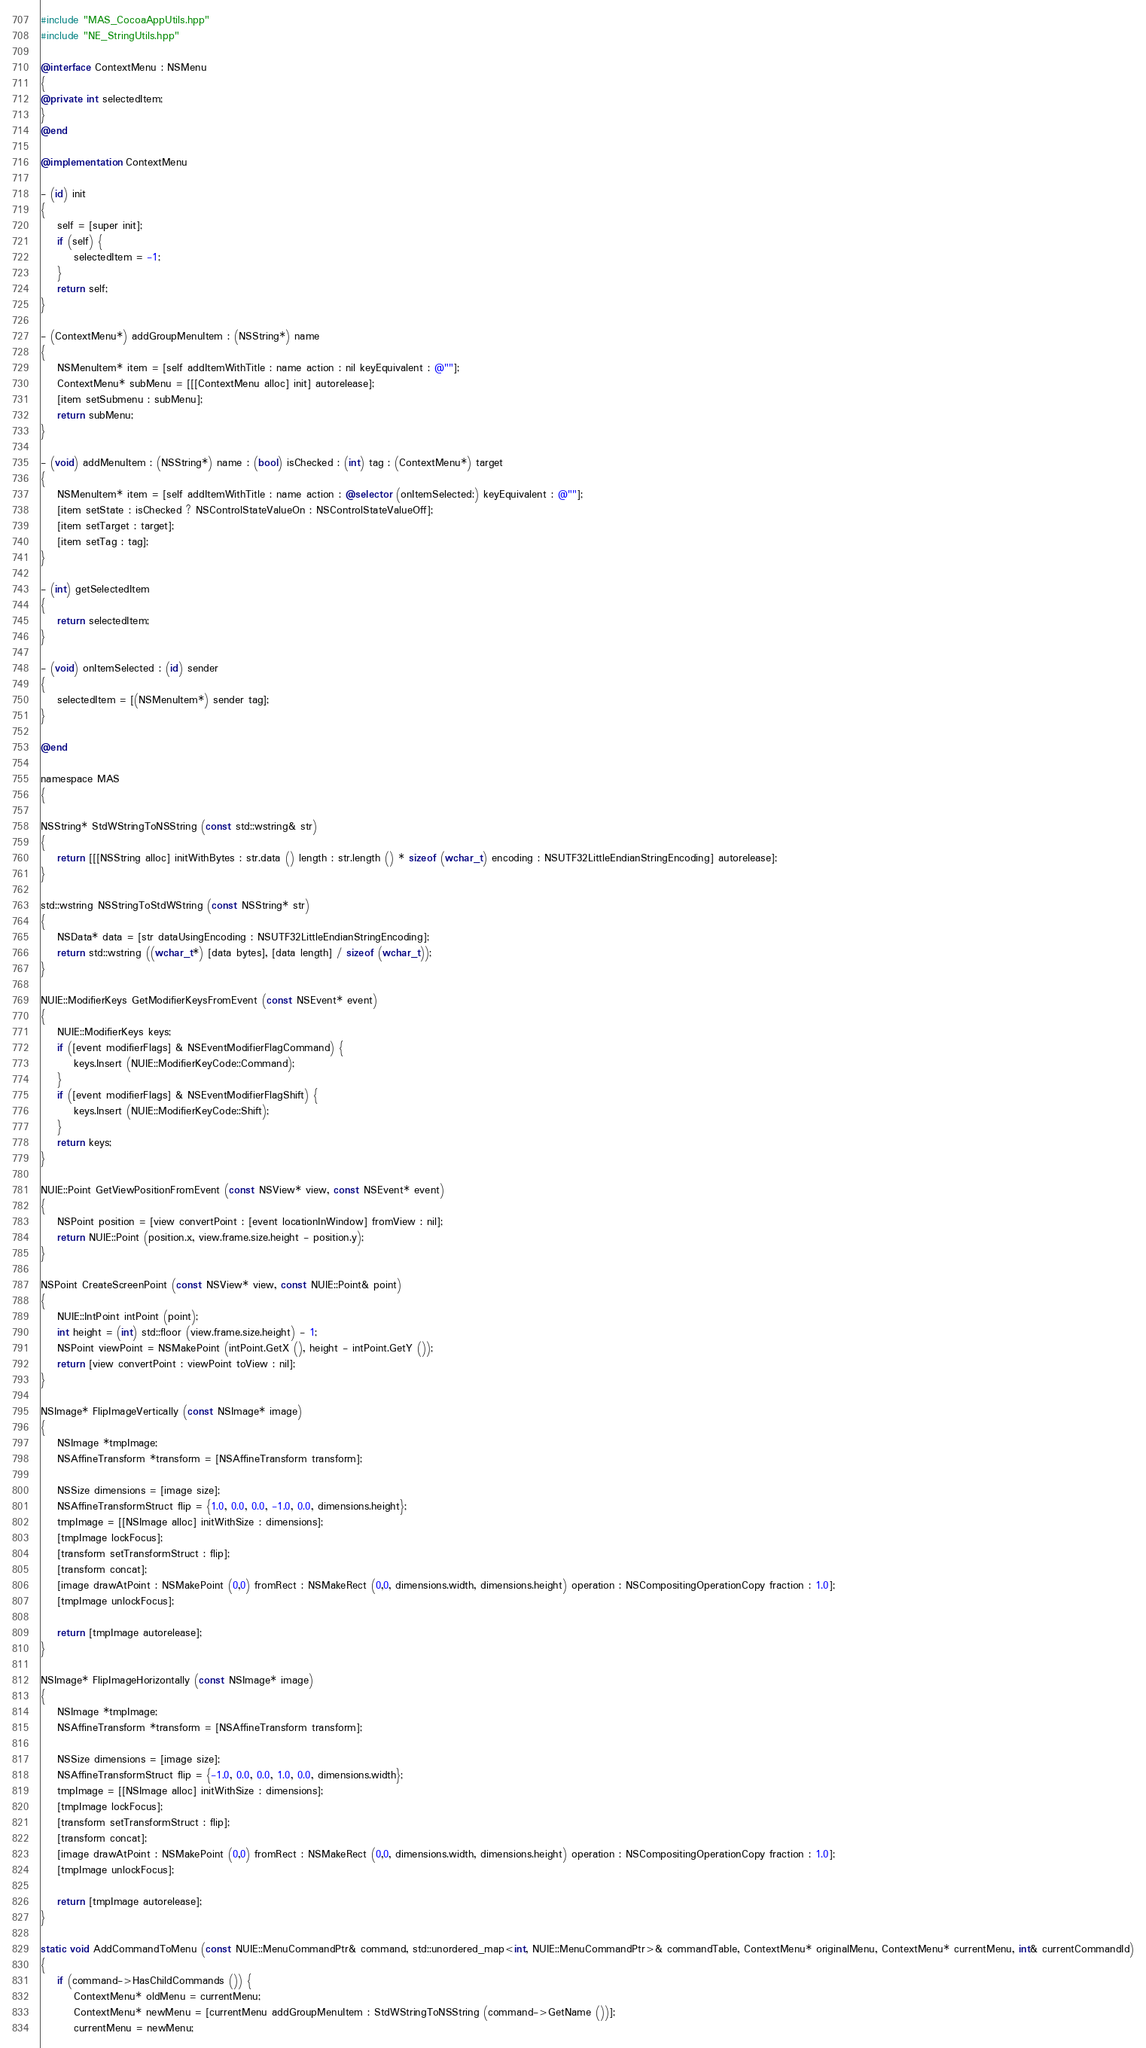Convert code to text. <code><loc_0><loc_0><loc_500><loc_500><_ObjectiveC_>#include "MAS_CocoaAppUtils.hpp"
#include "NE_StringUtils.hpp"

@interface ContextMenu : NSMenu
{
@private int selectedItem;
}
@end

@implementation ContextMenu

- (id) init
{
	self = [super init];
	if (self) {
		selectedItem = -1;
	}
	return self;
}

- (ContextMenu*) addGroupMenuItem : (NSString*) name
{
	NSMenuItem* item = [self addItemWithTitle : name action : nil keyEquivalent : @""];
	ContextMenu* subMenu = [[[ContextMenu alloc] init] autorelease];
	[item setSubmenu : subMenu];
	return subMenu;
}

- (void) addMenuItem : (NSString*) name : (bool) isChecked : (int) tag : (ContextMenu*) target
{
	NSMenuItem* item = [self addItemWithTitle : name action : @selector (onItemSelected:) keyEquivalent : @""];
	[item setState : isChecked ? NSControlStateValueOn : NSControlStateValueOff];
	[item setTarget : target];
	[item setTag : tag];
}

- (int) getSelectedItem
{
	return selectedItem;
}

- (void) onItemSelected : (id) sender
{
	selectedItem = [(NSMenuItem*) sender tag];
}

@end

namespace MAS
{

NSString* StdWStringToNSString (const std::wstring& str)
{
	return [[[NSString alloc] initWithBytes : str.data () length : str.length () * sizeof (wchar_t) encoding : NSUTF32LittleEndianStringEncoding] autorelease];
}

std::wstring NSStringToStdWString (const NSString* str)
{
    NSData* data = [str dataUsingEncoding : NSUTF32LittleEndianStringEncoding];
    return std::wstring ((wchar_t*) [data bytes], [data length] / sizeof (wchar_t));
}

NUIE::ModifierKeys GetModifierKeysFromEvent (const NSEvent* event)
{
	NUIE::ModifierKeys keys;
	if ([event modifierFlags] & NSEventModifierFlagCommand) {
		keys.Insert (NUIE::ModifierKeyCode::Command);
	}
	if ([event modifierFlags] & NSEventModifierFlagShift) {
		keys.Insert (NUIE::ModifierKeyCode::Shift);
	}
	return keys;
}

NUIE::Point GetViewPositionFromEvent (const NSView* view, const NSEvent* event)
{
	NSPoint position = [view convertPoint : [event locationInWindow] fromView : nil];
	return NUIE::Point (position.x, view.frame.size.height - position.y);
}

NSPoint CreateScreenPoint (const NSView* view, const NUIE::Point& point)
{
	NUIE::IntPoint intPoint (point);
	int height = (int) std::floor (view.frame.size.height) - 1;
	NSPoint viewPoint = NSMakePoint (intPoint.GetX (), height - intPoint.GetY ());
	return [view convertPoint : viewPoint toView : nil];
}

NSImage* FlipImageVertically (const NSImage* image)
{
	NSImage *tmpImage;
	NSAffineTransform *transform = [NSAffineTransform transform];

	NSSize dimensions = [image size];
	NSAffineTransformStruct flip = {1.0, 0.0, 0.0, -1.0, 0.0, dimensions.height};
	tmpImage = [[NSImage alloc] initWithSize : dimensions];
	[tmpImage lockFocus];
	[transform setTransformStruct : flip];
	[transform concat];
	[image drawAtPoint : NSMakePoint (0,0) fromRect : NSMakeRect (0,0, dimensions.width, dimensions.height) operation : NSCompositingOperationCopy fraction : 1.0];
	[tmpImage unlockFocus];

	return [tmpImage autorelease];
}

NSImage* FlipImageHorizontally (const NSImage* image)
{
	NSImage *tmpImage;
	NSAffineTransform *transform = [NSAffineTransform transform];

	NSSize dimensions = [image size];
	NSAffineTransformStruct flip = {-1.0, 0.0, 0.0, 1.0, 0.0, dimensions.width};
	tmpImage = [[NSImage alloc] initWithSize : dimensions];
	[tmpImage lockFocus];
	[transform setTransformStruct : flip];
	[transform concat];
	[image drawAtPoint : NSMakePoint (0,0) fromRect : NSMakeRect (0,0, dimensions.width, dimensions.height) operation : NSCompositingOperationCopy fraction : 1.0];
	[tmpImage unlockFocus];

	return [tmpImage autorelease];
}

static void AddCommandToMenu (const NUIE::MenuCommandPtr& command, std::unordered_map<int, NUIE::MenuCommandPtr>& commandTable, ContextMenu* originalMenu, ContextMenu* currentMenu, int& currentCommandId)
{
	if (command->HasChildCommands ()) {
		ContextMenu* oldMenu = currentMenu;
		ContextMenu* newMenu = [currentMenu addGroupMenuItem : StdWStringToNSString (command->GetName ())];
		currentMenu = newMenu;</code> 